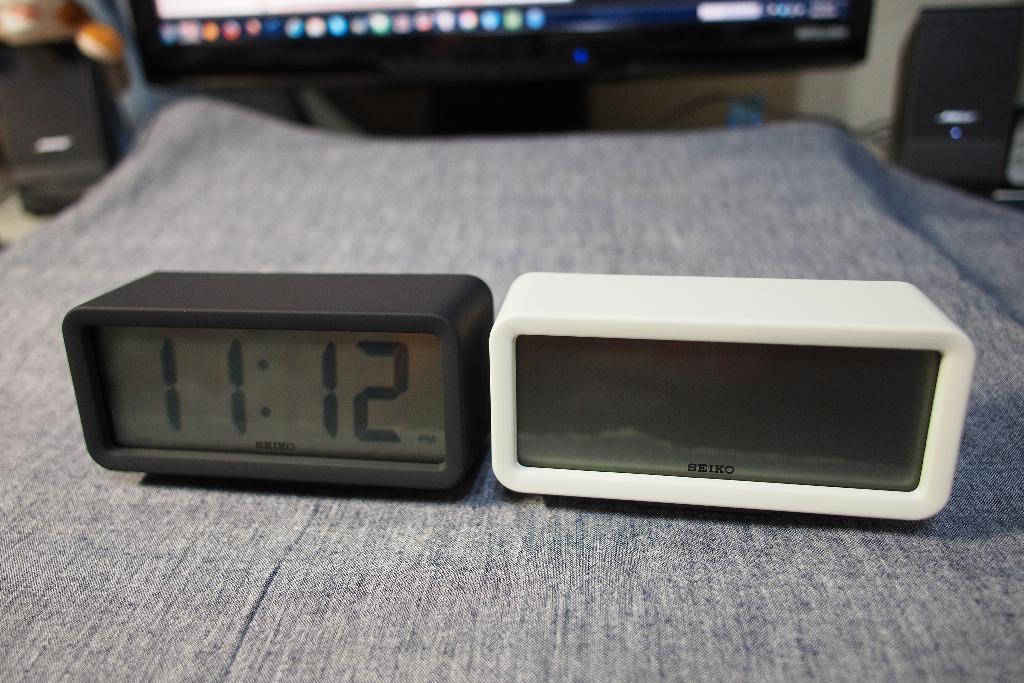What is the brand of the clocks?
Your response must be concise. Seiko. 